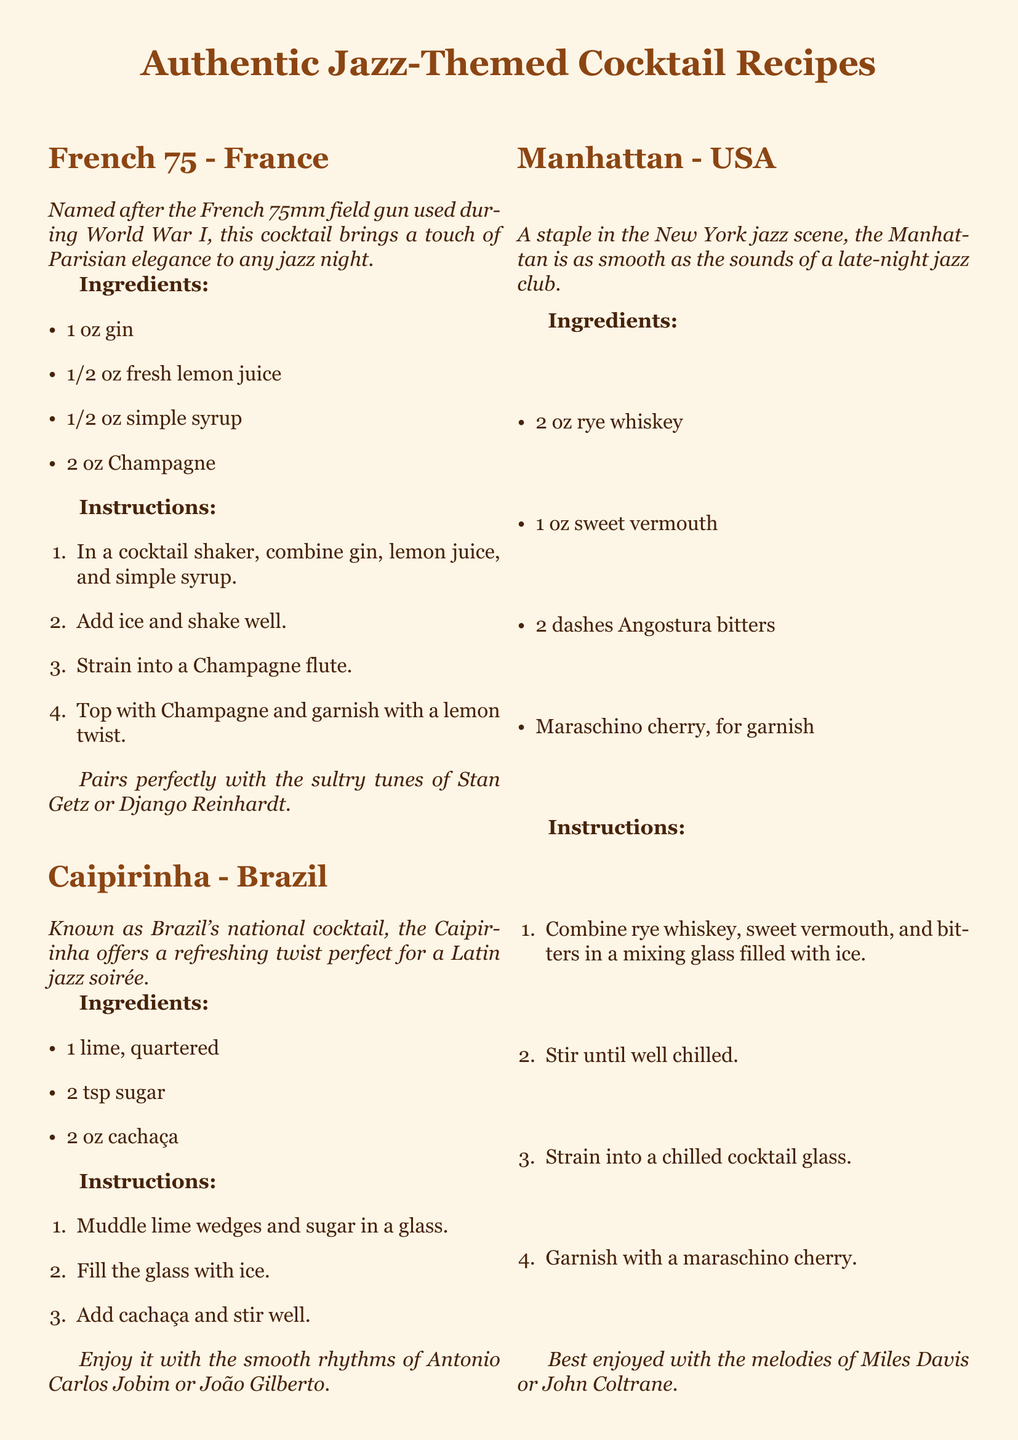What is the main ingredient in a French 75? The main ingredient in a French 75 is gin.
Answer: gin How many ounces of cachaça are needed for a Caipirinha? A Caipirinha requires 2 oz of cachaça.
Answer: 2 oz What cocktail is considered a staple in the New York jazz scene? The cocktail considered a staple in the New York jazz scene is the Manhattan.
Answer: Manhattan What is garnished on a Negroni? A Negroni is garnished with an orange peel.
Answer: orange peel How is a Japanese Highball garnished? A Japanese Highball is garnished with a lemon twist.
Answer: lemon twist Which cocktail pairs well with the melodies of Miles Davis? The cocktail that pairs well with the melodies of Miles Davis is the Manhattan.
Answer: Manhattan What type of music complements the Caipirinha? The Caipirinha is complemented by the smooth rhythms of Latin jazz.
Answer: Latin jazz What cocktail is named after a field gun? The cocktail named after a field gun is the French 75.
Answer: French 75 How many ingredients are listed for the Negroni? The Negroni has three ingredients listed.
Answer: Three 